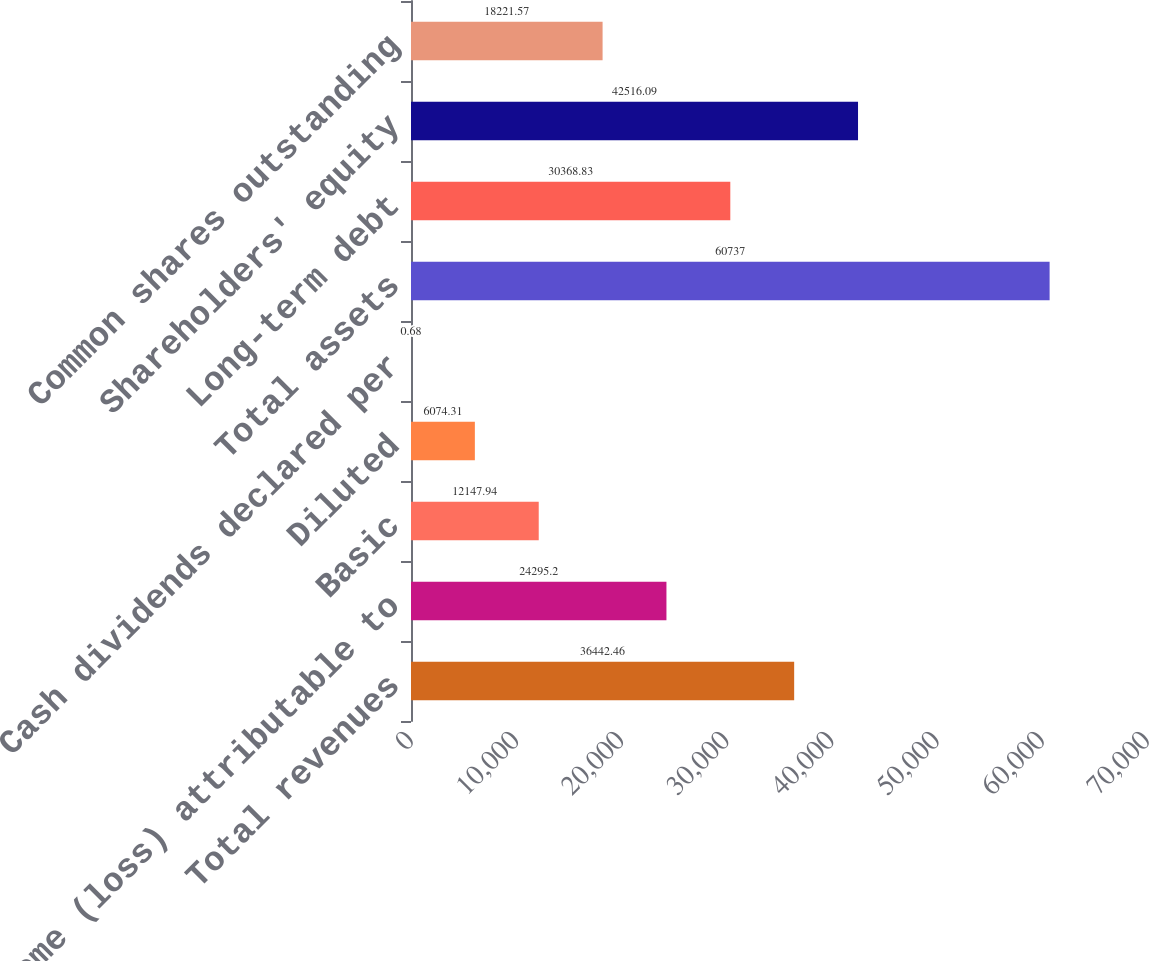Convert chart. <chart><loc_0><loc_0><loc_500><loc_500><bar_chart><fcel>Total revenues<fcel>Income (loss) attributable to<fcel>Basic<fcel>Diluted<fcel>Cash dividends declared per<fcel>Total assets<fcel>Long-term debt<fcel>Shareholders' equity<fcel>Common shares outstanding<nl><fcel>36442.5<fcel>24295.2<fcel>12147.9<fcel>6074.31<fcel>0.68<fcel>60737<fcel>30368.8<fcel>42516.1<fcel>18221.6<nl></chart> 